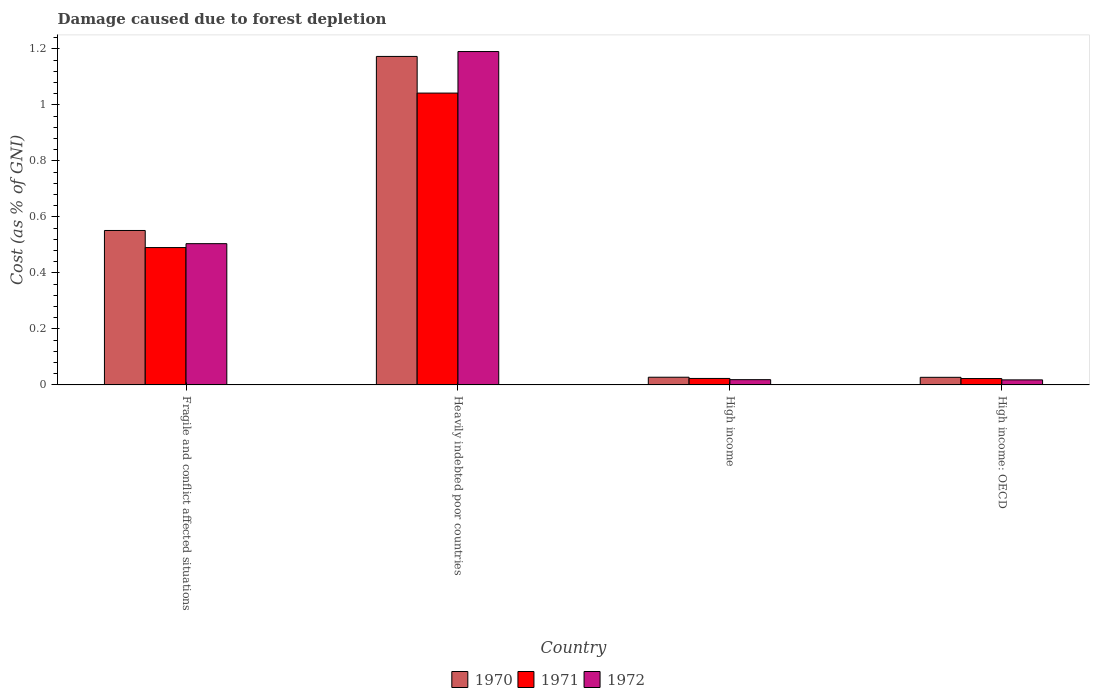How many different coloured bars are there?
Offer a very short reply. 3. How many groups of bars are there?
Give a very brief answer. 4. Are the number of bars on each tick of the X-axis equal?
Provide a succinct answer. Yes. How many bars are there on the 1st tick from the right?
Give a very brief answer. 3. What is the label of the 1st group of bars from the left?
Keep it short and to the point. Fragile and conflict affected situations. In how many cases, is the number of bars for a given country not equal to the number of legend labels?
Offer a very short reply. 0. What is the cost of damage caused due to forest depletion in 1971 in Fragile and conflict affected situations?
Ensure brevity in your answer.  0.49. Across all countries, what is the maximum cost of damage caused due to forest depletion in 1970?
Provide a succinct answer. 1.17. Across all countries, what is the minimum cost of damage caused due to forest depletion in 1971?
Ensure brevity in your answer.  0.02. In which country was the cost of damage caused due to forest depletion in 1972 maximum?
Your response must be concise. Heavily indebted poor countries. In which country was the cost of damage caused due to forest depletion in 1970 minimum?
Make the answer very short. High income: OECD. What is the total cost of damage caused due to forest depletion in 1970 in the graph?
Offer a terse response. 1.78. What is the difference between the cost of damage caused due to forest depletion in 1971 in High income and that in High income: OECD?
Offer a terse response. 0. What is the difference between the cost of damage caused due to forest depletion in 1972 in Heavily indebted poor countries and the cost of damage caused due to forest depletion in 1970 in High income?
Your answer should be compact. 1.16. What is the average cost of damage caused due to forest depletion in 1972 per country?
Give a very brief answer. 0.43. What is the difference between the cost of damage caused due to forest depletion of/in 1971 and cost of damage caused due to forest depletion of/in 1972 in High income: OECD?
Give a very brief answer. 0. In how many countries, is the cost of damage caused due to forest depletion in 1971 greater than 0.8 %?
Offer a very short reply. 1. What is the ratio of the cost of damage caused due to forest depletion in 1970 in High income to that in High income: OECD?
Your response must be concise. 1.01. What is the difference between the highest and the second highest cost of damage caused due to forest depletion in 1972?
Make the answer very short. -0.69. What is the difference between the highest and the lowest cost of damage caused due to forest depletion in 1970?
Your answer should be compact. 1.15. In how many countries, is the cost of damage caused due to forest depletion in 1971 greater than the average cost of damage caused due to forest depletion in 1971 taken over all countries?
Offer a terse response. 2. Is the sum of the cost of damage caused due to forest depletion in 1972 in Heavily indebted poor countries and High income: OECD greater than the maximum cost of damage caused due to forest depletion in 1970 across all countries?
Offer a terse response. Yes. What does the 2nd bar from the left in High income: OECD represents?
Ensure brevity in your answer.  1971. What does the 1st bar from the right in High income: OECD represents?
Make the answer very short. 1972. Is it the case that in every country, the sum of the cost of damage caused due to forest depletion in 1972 and cost of damage caused due to forest depletion in 1970 is greater than the cost of damage caused due to forest depletion in 1971?
Make the answer very short. Yes. How many bars are there?
Make the answer very short. 12. Are the values on the major ticks of Y-axis written in scientific E-notation?
Provide a short and direct response. No. Does the graph contain any zero values?
Your answer should be compact. No. Does the graph contain grids?
Your response must be concise. No. How many legend labels are there?
Make the answer very short. 3. How are the legend labels stacked?
Offer a terse response. Horizontal. What is the title of the graph?
Your answer should be very brief. Damage caused due to forest depletion. What is the label or title of the X-axis?
Provide a short and direct response. Country. What is the label or title of the Y-axis?
Give a very brief answer. Cost (as % of GNI). What is the Cost (as % of GNI) in 1970 in Fragile and conflict affected situations?
Make the answer very short. 0.55. What is the Cost (as % of GNI) of 1971 in Fragile and conflict affected situations?
Keep it short and to the point. 0.49. What is the Cost (as % of GNI) in 1972 in Fragile and conflict affected situations?
Your answer should be compact. 0.5. What is the Cost (as % of GNI) in 1970 in Heavily indebted poor countries?
Ensure brevity in your answer.  1.17. What is the Cost (as % of GNI) in 1971 in Heavily indebted poor countries?
Offer a terse response. 1.04. What is the Cost (as % of GNI) of 1972 in Heavily indebted poor countries?
Your answer should be compact. 1.19. What is the Cost (as % of GNI) of 1970 in High income?
Offer a terse response. 0.03. What is the Cost (as % of GNI) in 1971 in High income?
Your answer should be very brief. 0.02. What is the Cost (as % of GNI) in 1972 in High income?
Your answer should be compact. 0.02. What is the Cost (as % of GNI) of 1970 in High income: OECD?
Your answer should be very brief. 0.03. What is the Cost (as % of GNI) of 1971 in High income: OECD?
Keep it short and to the point. 0.02. What is the Cost (as % of GNI) of 1972 in High income: OECD?
Give a very brief answer. 0.02. Across all countries, what is the maximum Cost (as % of GNI) in 1970?
Provide a succinct answer. 1.17. Across all countries, what is the maximum Cost (as % of GNI) in 1971?
Ensure brevity in your answer.  1.04. Across all countries, what is the maximum Cost (as % of GNI) of 1972?
Keep it short and to the point. 1.19. Across all countries, what is the minimum Cost (as % of GNI) in 1970?
Offer a terse response. 0.03. Across all countries, what is the minimum Cost (as % of GNI) in 1971?
Keep it short and to the point. 0.02. Across all countries, what is the minimum Cost (as % of GNI) of 1972?
Offer a very short reply. 0.02. What is the total Cost (as % of GNI) in 1970 in the graph?
Keep it short and to the point. 1.78. What is the total Cost (as % of GNI) in 1971 in the graph?
Provide a short and direct response. 1.58. What is the total Cost (as % of GNI) in 1972 in the graph?
Provide a short and direct response. 1.73. What is the difference between the Cost (as % of GNI) in 1970 in Fragile and conflict affected situations and that in Heavily indebted poor countries?
Offer a terse response. -0.62. What is the difference between the Cost (as % of GNI) of 1971 in Fragile and conflict affected situations and that in Heavily indebted poor countries?
Ensure brevity in your answer.  -0.55. What is the difference between the Cost (as % of GNI) in 1972 in Fragile and conflict affected situations and that in Heavily indebted poor countries?
Ensure brevity in your answer.  -0.69. What is the difference between the Cost (as % of GNI) in 1970 in Fragile and conflict affected situations and that in High income?
Your answer should be compact. 0.52. What is the difference between the Cost (as % of GNI) of 1971 in Fragile and conflict affected situations and that in High income?
Make the answer very short. 0.47. What is the difference between the Cost (as % of GNI) in 1972 in Fragile and conflict affected situations and that in High income?
Offer a very short reply. 0.49. What is the difference between the Cost (as % of GNI) in 1970 in Fragile and conflict affected situations and that in High income: OECD?
Offer a terse response. 0.52. What is the difference between the Cost (as % of GNI) in 1971 in Fragile and conflict affected situations and that in High income: OECD?
Offer a very short reply. 0.47. What is the difference between the Cost (as % of GNI) in 1972 in Fragile and conflict affected situations and that in High income: OECD?
Keep it short and to the point. 0.49. What is the difference between the Cost (as % of GNI) in 1970 in Heavily indebted poor countries and that in High income?
Provide a short and direct response. 1.15. What is the difference between the Cost (as % of GNI) of 1971 in Heavily indebted poor countries and that in High income?
Ensure brevity in your answer.  1.02. What is the difference between the Cost (as % of GNI) of 1972 in Heavily indebted poor countries and that in High income?
Offer a terse response. 1.17. What is the difference between the Cost (as % of GNI) of 1970 in Heavily indebted poor countries and that in High income: OECD?
Provide a succinct answer. 1.15. What is the difference between the Cost (as % of GNI) in 1971 in Heavily indebted poor countries and that in High income: OECD?
Provide a succinct answer. 1.02. What is the difference between the Cost (as % of GNI) of 1972 in Heavily indebted poor countries and that in High income: OECD?
Offer a very short reply. 1.17. What is the difference between the Cost (as % of GNI) in 1971 in High income and that in High income: OECD?
Offer a very short reply. 0. What is the difference between the Cost (as % of GNI) in 1972 in High income and that in High income: OECD?
Provide a short and direct response. 0. What is the difference between the Cost (as % of GNI) in 1970 in Fragile and conflict affected situations and the Cost (as % of GNI) in 1971 in Heavily indebted poor countries?
Your response must be concise. -0.49. What is the difference between the Cost (as % of GNI) of 1970 in Fragile and conflict affected situations and the Cost (as % of GNI) of 1972 in Heavily indebted poor countries?
Ensure brevity in your answer.  -0.64. What is the difference between the Cost (as % of GNI) of 1970 in Fragile and conflict affected situations and the Cost (as % of GNI) of 1971 in High income?
Your answer should be very brief. 0.53. What is the difference between the Cost (as % of GNI) of 1970 in Fragile and conflict affected situations and the Cost (as % of GNI) of 1972 in High income?
Offer a terse response. 0.53. What is the difference between the Cost (as % of GNI) in 1971 in Fragile and conflict affected situations and the Cost (as % of GNI) in 1972 in High income?
Give a very brief answer. 0.47. What is the difference between the Cost (as % of GNI) in 1970 in Fragile and conflict affected situations and the Cost (as % of GNI) in 1971 in High income: OECD?
Ensure brevity in your answer.  0.53. What is the difference between the Cost (as % of GNI) of 1970 in Fragile and conflict affected situations and the Cost (as % of GNI) of 1972 in High income: OECD?
Provide a short and direct response. 0.53. What is the difference between the Cost (as % of GNI) of 1971 in Fragile and conflict affected situations and the Cost (as % of GNI) of 1972 in High income: OECD?
Make the answer very short. 0.47. What is the difference between the Cost (as % of GNI) in 1970 in Heavily indebted poor countries and the Cost (as % of GNI) in 1971 in High income?
Provide a short and direct response. 1.15. What is the difference between the Cost (as % of GNI) in 1970 in Heavily indebted poor countries and the Cost (as % of GNI) in 1972 in High income?
Your answer should be compact. 1.15. What is the difference between the Cost (as % of GNI) in 1971 in Heavily indebted poor countries and the Cost (as % of GNI) in 1972 in High income?
Provide a short and direct response. 1.02. What is the difference between the Cost (as % of GNI) in 1970 in Heavily indebted poor countries and the Cost (as % of GNI) in 1971 in High income: OECD?
Ensure brevity in your answer.  1.15. What is the difference between the Cost (as % of GNI) in 1970 in Heavily indebted poor countries and the Cost (as % of GNI) in 1972 in High income: OECD?
Ensure brevity in your answer.  1.15. What is the difference between the Cost (as % of GNI) of 1971 in Heavily indebted poor countries and the Cost (as % of GNI) of 1972 in High income: OECD?
Your answer should be very brief. 1.02. What is the difference between the Cost (as % of GNI) in 1970 in High income and the Cost (as % of GNI) in 1971 in High income: OECD?
Ensure brevity in your answer.  0. What is the difference between the Cost (as % of GNI) in 1970 in High income and the Cost (as % of GNI) in 1972 in High income: OECD?
Provide a short and direct response. 0.01. What is the difference between the Cost (as % of GNI) in 1971 in High income and the Cost (as % of GNI) in 1972 in High income: OECD?
Provide a succinct answer. 0.01. What is the average Cost (as % of GNI) in 1970 per country?
Give a very brief answer. 0.44. What is the average Cost (as % of GNI) of 1971 per country?
Your answer should be compact. 0.39. What is the average Cost (as % of GNI) in 1972 per country?
Provide a short and direct response. 0.43. What is the difference between the Cost (as % of GNI) of 1970 and Cost (as % of GNI) of 1971 in Fragile and conflict affected situations?
Your response must be concise. 0.06. What is the difference between the Cost (as % of GNI) in 1970 and Cost (as % of GNI) in 1972 in Fragile and conflict affected situations?
Offer a very short reply. 0.05. What is the difference between the Cost (as % of GNI) in 1971 and Cost (as % of GNI) in 1972 in Fragile and conflict affected situations?
Offer a very short reply. -0.01. What is the difference between the Cost (as % of GNI) in 1970 and Cost (as % of GNI) in 1971 in Heavily indebted poor countries?
Keep it short and to the point. 0.13. What is the difference between the Cost (as % of GNI) of 1970 and Cost (as % of GNI) of 1972 in Heavily indebted poor countries?
Your answer should be very brief. -0.02. What is the difference between the Cost (as % of GNI) of 1971 and Cost (as % of GNI) of 1972 in Heavily indebted poor countries?
Keep it short and to the point. -0.15. What is the difference between the Cost (as % of GNI) of 1970 and Cost (as % of GNI) of 1971 in High income?
Your answer should be compact. 0. What is the difference between the Cost (as % of GNI) in 1970 and Cost (as % of GNI) in 1972 in High income?
Keep it short and to the point. 0.01. What is the difference between the Cost (as % of GNI) in 1971 and Cost (as % of GNI) in 1972 in High income?
Make the answer very short. 0. What is the difference between the Cost (as % of GNI) in 1970 and Cost (as % of GNI) in 1971 in High income: OECD?
Keep it short and to the point. 0. What is the difference between the Cost (as % of GNI) of 1970 and Cost (as % of GNI) of 1972 in High income: OECD?
Make the answer very short. 0.01. What is the difference between the Cost (as % of GNI) of 1971 and Cost (as % of GNI) of 1972 in High income: OECD?
Your answer should be very brief. 0. What is the ratio of the Cost (as % of GNI) of 1970 in Fragile and conflict affected situations to that in Heavily indebted poor countries?
Give a very brief answer. 0.47. What is the ratio of the Cost (as % of GNI) of 1971 in Fragile and conflict affected situations to that in Heavily indebted poor countries?
Provide a succinct answer. 0.47. What is the ratio of the Cost (as % of GNI) of 1972 in Fragile and conflict affected situations to that in Heavily indebted poor countries?
Give a very brief answer. 0.42. What is the ratio of the Cost (as % of GNI) of 1970 in Fragile and conflict affected situations to that in High income?
Your response must be concise. 20.11. What is the ratio of the Cost (as % of GNI) in 1971 in Fragile and conflict affected situations to that in High income?
Provide a short and direct response. 21.22. What is the ratio of the Cost (as % of GNI) in 1972 in Fragile and conflict affected situations to that in High income?
Provide a short and direct response. 26.95. What is the ratio of the Cost (as % of GNI) in 1970 in Fragile and conflict affected situations to that in High income: OECD?
Make the answer very short. 20.35. What is the ratio of the Cost (as % of GNI) of 1971 in Fragile and conflict affected situations to that in High income: OECD?
Offer a very short reply. 21.58. What is the ratio of the Cost (as % of GNI) in 1972 in Fragile and conflict affected situations to that in High income: OECD?
Your answer should be very brief. 28.05. What is the ratio of the Cost (as % of GNI) of 1970 in Heavily indebted poor countries to that in High income?
Your answer should be compact. 42.78. What is the ratio of the Cost (as % of GNI) in 1971 in Heavily indebted poor countries to that in High income?
Your answer should be very brief. 45.1. What is the ratio of the Cost (as % of GNI) of 1972 in Heavily indebted poor countries to that in High income?
Offer a very short reply. 63.61. What is the ratio of the Cost (as % of GNI) in 1970 in Heavily indebted poor countries to that in High income: OECD?
Your answer should be compact. 43.29. What is the ratio of the Cost (as % of GNI) in 1971 in Heavily indebted poor countries to that in High income: OECD?
Your response must be concise. 45.86. What is the ratio of the Cost (as % of GNI) in 1972 in Heavily indebted poor countries to that in High income: OECD?
Keep it short and to the point. 66.22. What is the ratio of the Cost (as % of GNI) in 1971 in High income to that in High income: OECD?
Provide a short and direct response. 1.02. What is the ratio of the Cost (as % of GNI) of 1972 in High income to that in High income: OECD?
Your response must be concise. 1.04. What is the difference between the highest and the second highest Cost (as % of GNI) in 1970?
Provide a short and direct response. 0.62. What is the difference between the highest and the second highest Cost (as % of GNI) in 1971?
Your answer should be compact. 0.55. What is the difference between the highest and the second highest Cost (as % of GNI) of 1972?
Make the answer very short. 0.69. What is the difference between the highest and the lowest Cost (as % of GNI) in 1970?
Your answer should be compact. 1.15. What is the difference between the highest and the lowest Cost (as % of GNI) in 1971?
Ensure brevity in your answer.  1.02. What is the difference between the highest and the lowest Cost (as % of GNI) of 1972?
Make the answer very short. 1.17. 